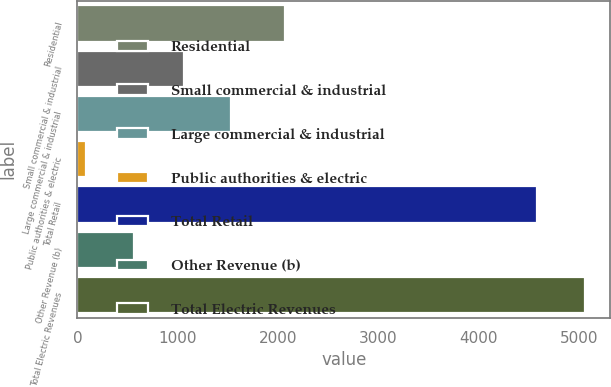<chart> <loc_0><loc_0><loc_500><loc_500><bar_chart><fcel>Residential<fcel>Small commercial & industrial<fcel>Large commercial & industrial<fcel>Public authorities & electric<fcel>Total Retail<fcel>Other Revenue (b)<fcel>Total Electric Revenues<nl><fcel>2069<fcel>1061<fcel>1535.6<fcel>89<fcel>4583<fcel>563.6<fcel>5057.6<nl></chart> 